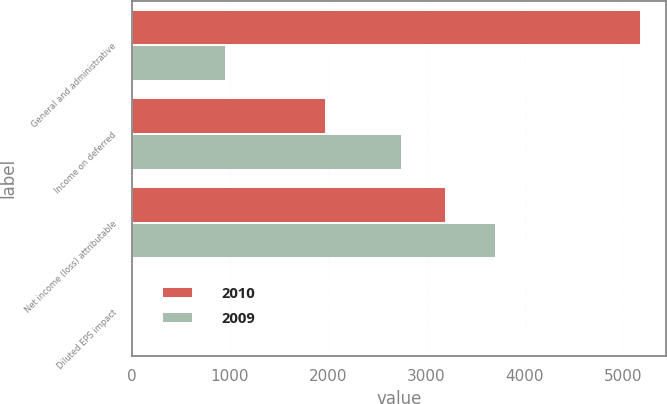Convert chart to OTSL. <chart><loc_0><loc_0><loc_500><loc_500><stacked_bar_chart><ecel><fcel>General and administrative<fcel>Income on deferred<fcel>Net income (loss) attributable<fcel>Diluted EPS impact<nl><fcel>2010<fcel>5180<fcel>1982<fcel>3198<fcel>0.04<nl><fcel>2009<fcel>956<fcel>2750<fcel>3706<fcel>0.05<nl></chart> 